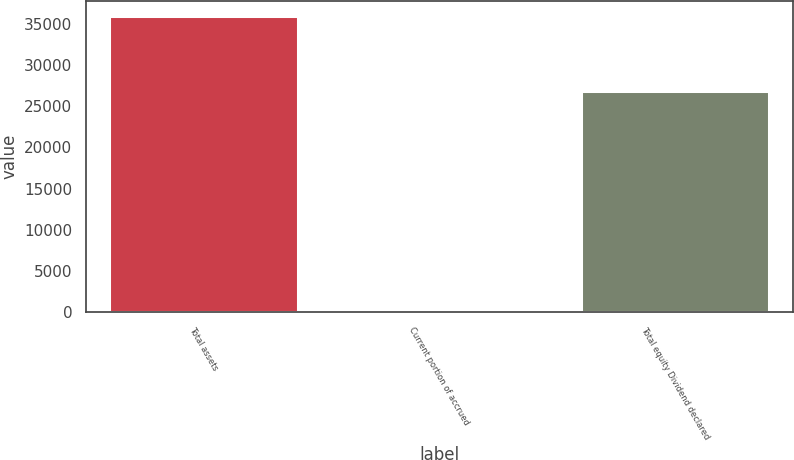<chart> <loc_0><loc_0><loc_500><loc_500><bar_chart><fcel>Total assets<fcel>Current portion of accrued<fcel>Total equity Dividend declared<nl><fcel>35956<fcel>5<fcel>26870<nl></chart> 